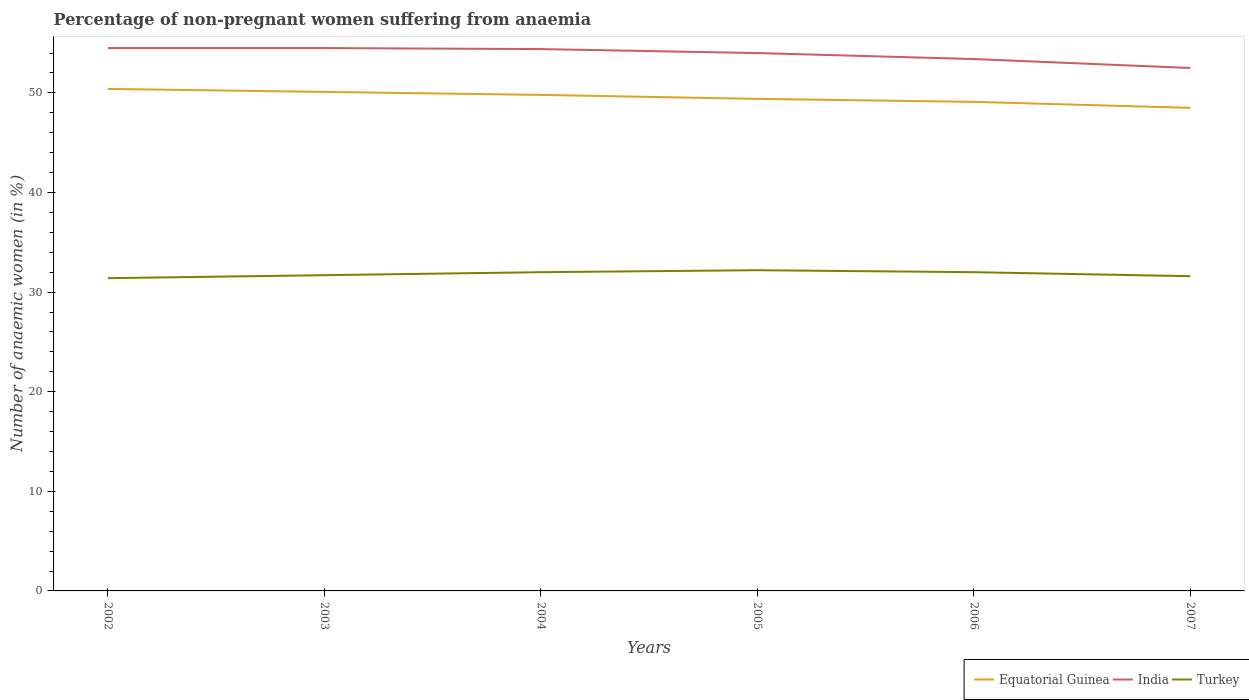Does the line corresponding to Equatorial Guinea intersect with the line corresponding to India?
Provide a succinct answer. No. Across all years, what is the maximum percentage of non-pregnant women suffering from anaemia in Turkey?
Provide a short and direct response. 31.4. In which year was the percentage of non-pregnant women suffering from anaemia in India maximum?
Make the answer very short. 2007. What is the total percentage of non-pregnant women suffering from anaemia in Equatorial Guinea in the graph?
Keep it short and to the point. 0.7. What is the difference between the highest and the second highest percentage of non-pregnant women suffering from anaemia in India?
Keep it short and to the point. 2. What is the difference between the highest and the lowest percentage of non-pregnant women suffering from anaemia in Equatorial Guinea?
Give a very brief answer. 3. What is the difference between two consecutive major ticks on the Y-axis?
Keep it short and to the point. 10. What is the title of the graph?
Keep it short and to the point. Percentage of non-pregnant women suffering from anaemia. Does "Yemen, Rep." appear as one of the legend labels in the graph?
Your answer should be very brief. No. What is the label or title of the Y-axis?
Your answer should be very brief. Number of anaemic women (in %). What is the Number of anaemic women (in %) of Equatorial Guinea in 2002?
Make the answer very short. 50.4. What is the Number of anaemic women (in %) of India in 2002?
Make the answer very short. 54.5. What is the Number of anaemic women (in %) of Turkey in 2002?
Your answer should be compact. 31.4. What is the Number of anaemic women (in %) in Equatorial Guinea in 2003?
Your answer should be very brief. 50.1. What is the Number of anaemic women (in %) in India in 2003?
Provide a succinct answer. 54.5. What is the Number of anaemic women (in %) in Turkey in 2003?
Provide a short and direct response. 31.7. What is the Number of anaemic women (in %) in Equatorial Guinea in 2004?
Keep it short and to the point. 49.8. What is the Number of anaemic women (in %) of India in 2004?
Provide a succinct answer. 54.4. What is the Number of anaemic women (in %) of Turkey in 2004?
Your answer should be compact. 32. What is the Number of anaemic women (in %) in Equatorial Guinea in 2005?
Offer a very short reply. 49.4. What is the Number of anaemic women (in %) in India in 2005?
Your answer should be very brief. 54. What is the Number of anaemic women (in %) in Turkey in 2005?
Ensure brevity in your answer.  32.2. What is the Number of anaemic women (in %) of Equatorial Guinea in 2006?
Give a very brief answer. 49.1. What is the Number of anaemic women (in %) of India in 2006?
Your response must be concise. 53.4. What is the Number of anaemic women (in %) of Equatorial Guinea in 2007?
Give a very brief answer. 48.5. What is the Number of anaemic women (in %) in India in 2007?
Offer a terse response. 52.5. What is the Number of anaemic women (in %) of Turkey in 2007?
Your answer should be compact. 31.6. Across all years, what is the maximum Number of anaemic women (in %) of Equatorial Guinea?
Make the answer very short. 50.4. Across all years, what is the maximum Number of anaemic women (in %) of India?
Provide a short and direct response. 54.5. Across all years, what is the maximum Number of anaemic women (in %) of Turkey?
Offer a terse response. 32.2. Across all years, what is the minimum Number of anaemic women (in %) of Equatorial Guinea?
Your answer should be very brief. 48.5. Across all years, what is the minimum Number of anaemic women (in %) in India?
Offer a terse response. 52.5. Across all years, what is the minimum Number of anaemic women (in %) in Turkey?
Offer a terse response. 31.4. What is the total Number of anaemic women (in %) in Equatorial Guinea in the graph?
Give a very brief answer. 297.3. What is the total Number of anaemic women (in %) of India in the graph?
Your response must be concise. 323.3. What is the total Number of anaemic women (in %) in Turkey in the graph?
Give a very brief answer. 190.9. What is the difference between the Number of anaemic women (in %) of Equatorial Guinea in 2002 and that in 2003?
Your answer should be very brief. 0.3. What is the difference between the Number of anaemic women (in %) in India in 2002 and that in 2003?
Your answer should be compact. 0. What is the difference between the Number of anaemic women (in %) of Equatorial Guinea in 2002 and that in 2004?
Give a very brief answer. 0.6. What is the difference between the Number of anaemic women (in %) of India in 2002 and that in 2004?
Make the answer very short. 0.1. What is the difference between the Number of anaemic women (in %) in Equatorial Guinea in 2002 and that in 2005?
Offer a terse response. 1. What is the difference between the Number of anaemic women (in %) of Turkey in 2002 and that in 2005?
Provide a short and direct response. -0.8. What is the difference between the Number of anaemic women (in %) in Equatorial Guinea in 2002 and that in 2007?
Your answer should be compact. 1.9. What is the difference between the Number of anaemic women (in %) of India in 2002 and that in 2007?
Make the answer very short. 2. What is the difference between the Number of anaemic women (in %) of Equatorial Guinea in 2003 and that in 2004?
Provide a short and direct response. 0.3. What is the difference between the Number of anaemic women (in %) in India in 2003 and that in 2004?
Offer a very short reply. 0.1. What is the difference between the Number of anaemic women (in %) in Equatorial Guinea in 2003 and that in 2005?
Offer a very short reply. 0.7. What is the difference between the Number of anaemic women (in %) in Equatorial Guinea in 2003 and that in 2006?
Make the answer very short. 1. What is the difference between the Number of anaemic women (in %) of Equatorial Guinea in 2003 and that in 2007?
Provide a short and direct response. 1.6. What is the difference between the Number of anaemic women (in %) in Turkey in 2003 and that in 2007?
Your answer should be very brief. 0.1. What is the difference between the Number of anaemic women (in %) in India in 2004 and that in 2005?
Provide a succinct answer. 0.4. What is the difference between the Number of anaemic women (in %) of Turkey in 2004 and that in 2005?
Your answer should be compact. -0.2. What is the difference between the Number of anaemic women (in %) of Turkey in 2004 and that in 2006?
Offer a terse response. 0. What is the difference between the Number of anaemic women (in %) of Equatorial Guinea in 2004 and that in 2007?
Ensure brevity in your answer.  1.3. What is the difference between the Number of anaemic women (in %) in Turkey in 2004 and that in 2007?
Provide a short and direct response. 0.4. What is the difference between the Number of anaemic women (in %) in India in 2005 and that in 2006?
Keep it short and to the point. 0.6. What is the difference between the Number of anaemic women (in %) of Equatorial Guinea in 2005 and that in 2007?
Provide a succinct answer. 0.9. What is the difference between the Number of anaemic women (in %) of Turkey in 2005 and that in 2007?
Provide a short and direct response. 0.6. What is the difference between the Number of anaemic women (in %) in Equatorial Guinea in 2006 and that in 2007?
Offer a terse response. 0.6. What is the difference between the Number of anaemic women (in %) in Equatorial Guinea in 2002 and the Number of anaemic women (in %) in India in 2003?
Provide a short and direct response. -4.1. What is the difference between the Number of anaemic women (in %) in Equatorial Guinea in 2002 and the Number of anaemic women (in %) in Turkey in 2003?
Ensure brevity in your answer.  18.7. What is the difference between the Number of anaemic women (in %) in India in 2002 and the Number of anaemic women (in %) in Turkey in 2003?
Ensure brevity in your answer.  22.8. What is the difference between the Number of anaemic women (in %) in Equatorial Guinea in 2002 and the Number of anaemic women (in %) in India in 2004?
Ensure brevity in your answer.  -4. What is the difference between the Number of anaemic women (in %) of Equatorial Guinea in 2002 and the Number of anaemic women (in %) of Turkey in 2004?
Keep it short and to the point. 18.4. What is the difference between the Number of anaemic women (in %) in Equatorial Guinea in 2002 and the Number of anaemic women (in %) in India in 2005?
Give a very brief answer. -3.6. What is the difference between the Number of anaemic women (in %) in India in 2002 and the Number of anaemic women (in %) in Turkey in 2005?
Your answer should be compact. 22.3. What is the difference between the Number of anaemic women (in %) in Equatorial Guinea in 2002 and the Number of anaemic women (in %) in Turkey in 2006?
Your response must be concise. 18.4. What is the difference between the Number of anaemic women (in %) in Equatorial Guinea in 2002 and the Number of anaemic women (in %) in India in 2007?
Your answer should be very brief. -2.1. What is the difference between the Number of anaemic women (in %) in India in 2002 and the Number of anaemic women (in %) in Turkey in 2007?
Provide a succinct answer. 22.9. What is the difference between the Number of anaemic women (in %) in Equatorial Guinea in 2003 and the Number of anaemic women (in %) in India in 2004?
Offer a terse response. -4.3. What is the difference between the Number of anaemic women (in %) in Equatorial Guinea in 2003 and the Number of anaemic women (in %) in Turkey in 2004?
Your response must be concise. 18.1. What is the difference between the Number of anaemic women (in %) of Equatorial Guinea in 2003 and the Number of anaemic women (in %) of India in 2005?
Your answer should be compact. -3.9. What is the difference between the Number of anaemic women (in %) in Equatorial Guinea in 2003 and the Number of anaemic women (in %) in Turkey in 2005?
Offer a terse response. 17.9. What is the difference between the Number of anaemic women (in %) in India in 2003 and the Number of anaemic women (in %) in Turkey in 2005?
Make the answer very short. 22.3. What is the difference between the Number of anaemic women (in %) in Equatorial Guinea in 2003 and the Number of anaemic women (in %) in India in 2006?
Offer a terse response. -3.3. What is the difference between the Number of anaemic women (in %) of India in 2003 and the Number of anaemic women (in %) of Turkey in 2006?
Your answer should be compact. 22.5. What is the difference between the Number of anaemic women (in %) in Equatorial Guinea in 2003 and the Number of anaemic women (in %) in India in 2007?
Make the answer very short. -2.4. What is the difference between the Number of anaemic women (in %) of Equatorial Guinea in 2003 and the Number of anaemic women (in %) of Turkey in 2007?
Make the answer very short. 18.5. What is the difference between the Number of anaemic women (in %) of India in 2003 and the Number of anaemic women (in %) of Turkey in 2007?
Ensure brevity in your answer.  22.9. What is the difference between the Number of anaemic women (in %) in Equatorial Guinea in 2004 and the Number of anaemic women (in %) in India in 2005?
Provide a short and direct response. -4.2. What is the difference between the Number of anaemic women (in %) of Equatorial Guinea in 2004 and the Number of anaemic women (in %) of India in 2006?
Your response must be concise. -3.6. What is the difference between the Number of anaemic women (in %) in Equatorial Guinea in 2004 and the Number of anaemic women (in %) in Turkey in 2006?
Provide a short and direct response. 17.8. What is the difference between the Number of anaemic women (in %) of India in 2004 and the Number of anaemic women (in %) of Turkey in 2006?
Offer a terse response. 22.4. What is the difference between the Number of anaemic women (in %) in India in 2004 and the Number of anaemic women (in %) in Turkey in 2007?
Your answer should be very brief. 22.8. What is the difference between the Number of anaemic women (in %) of Equatorial Guinea in 2005 and the Number of anaemic women (in %) of India in 2006?
Give a very brief answer. -4. What is the difference between the Number of anaemic women (in %) in Equatorial Guinea in 2005 and the Number of anaemic women (in %) in Turkey in 2006?
Make the answer very short. 17.4. What is the difference between the Number of anaemic women (in %) of Equatorial Guinea in 2005 and the Number of anaemic women (in %) of Turkey in 2007?
Make the answer very short. 17.8. What is the difference between the Number of anaemic women (in %) in India in 2005 and the Number of anaemic women (in %) in Turkey in 2007?
Make the answer very short. 22.4. What is the difference between the Number of anaemic women (in %) in Equatorial Guinea in 2006 and the Number of anaemic women (in %) in India in 2007?
Your answer should be very brief. -3.4. What is the difference between the Number of anaemic women (in %) in India in 2006 and the Number of anaemic women (in %) in Turkey in 2007?
Keep it short and to the point. 21.8. What is the average Number of anaemic women (in %) in Equatorial Guinea per year?
Provide a succinct answer. 49.55. What is the average Number of anaemic women (in %) in India per year?
Keep it short and to the point. 53.88. What is the average Number of anaemic women (in %) in Turkey per year?
Keep it short and to the point. 31.82. In the year 2002, what is the difference between the Number of anaemic women (in %) in Equatorial Guinea and Number of anaemic women (in %) in Turkey?
Offer a terse response. 19. In the year 2002, what is the difference between the Number of anaemic women (in %) in India and Number of anaemic women (in %) in Turkey?
Your answer should be very brief. 23.1. In the year 2003, what is the difference between the Number of anaemic women (in %) in Equatorial Guinea and Number of anaemic women (in %) in Turkey?
Keep it short and to the point. 18.4. In the year 2003, what is the difference between the Number of anaemic women (in %) in India and Number of anaemic women (in %) in Turkey?
Give a very brief answer. 22.8. In the year 2004, what is the difference between the Number of anaemic women (in %) of Equatorial Guinea and Number of anaemic women (in %) of Turkey?
Offer a terse response. 17.8. In the year 2004, what is the difference between the Number of anaemic women (in %) of India and Number of anaemic women (in %) of Turkey?
Provide a short and direct response. 22.4. In the year 2005, what is the difference between the Number of anaemic women (in %) in Equatorial Guinea and Number of anaemic women (in %) in India?
Offer a very short reply. -4.6. In the year 2005, what is the difference between the Number of anaemic women (in %) of India and Number of anaemic women (in %) of Turkey?
Offer a terse response. 21.8. In the year 2006, what is the difference between the Number of anaemic women (in %) of India and Number of anaemic women (in %) of Turkey?
Your response must be concise. 21.4. In the year 2007, what is the difference between the Number of anaemic women (in %) in Equatorial Guinea and Number of anaemic women (in %) in Turkey?
Your response must be concise. 16.9. In the year 2007, what is the difference between the Number of anaemic women (in %) in India and Number of anaemic women (in %) in Turkey?
Provide a short and direct response. 20.9. What is the ratio of the Number of anaemic women (in %) of India in 2002 to that in 2003?
Your answer should be compact. 1. What is the ratio of the Number of anaemic women (in %) in Turkey in 2002 to that in 2003?
Offer a terse response. 0.99. What is the ratio of the Number of anaemic women (in %) in Equatorial Guinea in 2002 to that in 2004?
Your response must be concise. 1.01. What is the ratio of the Number of anaemic women (in %) in India in 2002 to that in 2004?
Make the answer very short. 1. What is the ratio of the Number of anaemic women (in %) in Turkey in 2002 to that in 2004?
Make the answer very short. 0.98. What is the ratio of the Number of anaemic women (in %) in Equatorial Guinea in 2002 to that in 2005?
Provide a short and direct response. 1.02. What is the ratio of the Number of anaemic women (in %) of India in 2002 to that in 2005?
Your answer should be very brief. 1.01. What is the ratio of the Number of anaemic women (in %) of Turkey in 2002 to that in 2005?
Offer a very short reply. 0.98. What is the ratio of the Number of anaemic women (in %) of Equatorial Guinea in 2002 to that in 2006?
Ensure brevity in your answer.  1.03. What is the ratio of the Number of anaemic women (in %) in India in 2002 to that in 2006?
Your answer should be compact. 1.02. What is the ratio of the Number of anaemic women (in %) in Turkey in 2002 to that in 2006?
Provide a short and direct response. 0.98. What is the ratio of the Number of anaemic women (in %) in Equatorial Guinea in 2002 to that in 2007?
Provide a succinct answer. 1.04. What is the ratio of the Number of anaemic women (in %) in India in 2002 to that in 2007?
Provide a succinct answer. 1.04. What is the ratio of the Number of anaemic women (in %) in Turkey in 2002 to that in 2007?
Provide a succinct answer. 0.99. What is the ratio of the Number of anaemic women (in %) of Equatorial Guinea in 2003 to that in 2004?
Your answer should be very brief. 1.01. What is the ratio of the Number of anaemic women (in %) in Turkey in 2003 to that in 2004?
Your answer should be very brief. 0.99. What is the ratio of the Number of anaemic women (in %) in Equatorial Guinea in 2003 to that in 2005?
Offer a very short reply. 1.01. What is the ratio of the Number of anaemic women (in %) in India in 2003 to that in 2005?
Keep it short and to the point. 1.01. What is the ratio of the Number of anaemic women (in %) in Turkey in 2003 to that in 2005?
Offer a very short reply. 0.98. What is the ratio of the Number of anaemic women (in %) in Equatorial Guinea in 2003 to that in 2006?
Offer a terse response. 1.02. What is the ratio of the Number of anaemic women (in %) of India in 2003 to that in 2006?
Your answer should be very brief. 1.02. What is the ratio of the Number of anaemic women (in %) in Turkey in 2003 to that in 2006?
Your answer should be very brief. 0.99. What is the ratio of the Number of anaemic women (in %) of Equatorial Guinea in 2003 to that in 2007?
Your response must be concise. 1.03. What is the ratio of the Number of anaemic women (in %) of India in 2003 to that in 2007?
Your answer should be compact. 1.04. What is the ratio of the Number of anaemic women (in %) of Turkey in 2003 to that in 2007?
Keep it short and to the point. 1. What is the ratio of the Number of anaemic women (in %) in Equatorial Guinea in 2004 to that in 2005?
Keep it short and to the point. 1.01. What is the ratio of the Number of anaemic women (in %) in India in 2004 to that in 2005?
Your answer should be very brief. 1.01. What is the ratio of the Number of anaemic women (in %) of Turkey in 2004 to that in 2005?
Offer a terse response. 0.99. What is the ratio of the Number of anaemic women (in %) in Equatorial Guinea in 2004 to that in 2006?
Give a very brief answer. 1.01. What is the ratio of the Number of anaemic women (in %) in India in 2004 to that in 2006?
Make the answer very short. 1.02. What is the ratio of the Number of anaemic women (in %) in Equatorial Guinea in 2004 to that in 2007?
Offer a terse response. 1.03. What is the ratio of the Number of anaemic women (in %) of India in 2004 to that in 2007?
Provide a short and direct response. 1.04. What is the ratio of the Number of anaemic women (in %) in Turkey in 2004 to that in 2007?
Provide a succinct answer. 1.01. What is the ratio of the Number of anaemic women (in %) of India in 2005 to that in 2006?
Give a very brief answer. 1.01. What is the ratio of the Number of anaemic women (in %) of Turkey in 2005 to that in 2006?
Offer a terse response. 1.01. What is the ratio of the Number of anaemic women (in %) in Equatorial Guinea in 2005 to that in 2007?
Keep it short and to the point. 1.02. What is the ratio of the Number of anaemic women (in %) of India in 2005 to that in 2007?
Give a very brief answer. 1.03. What is the ratio of the Number of anaemic women (in %) in Equatorial Guinea in 2006 to that in 2007?
Give a very brief answer. 1.01. What is the ratio of the Number of anaemic women (in %) in India in 2006 to that in 2007?
Your answer should be very brief. 1.02. What is the ratio of the Number of anaemic women (in %) in Turkey in 2006 to that in 2007?
Keep it short and to the point. 1.01. What is the difference between the highest and the lowest Number of anaemic women (in %) in Equatorial Guinea?
Provide a short and direct response. 1.9. What is the difference between the highest and the lowest Number of anaemic women (in %) in India?
Offer a very short reply. 2. 